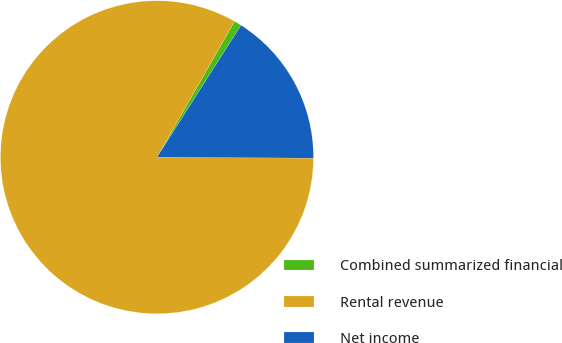<chart> <loc_0><loc_0><loc_500><loc_500><pie_chart><fcel>Combined summarized financial<fcel>Rental revenue<fcel>Net income<nl><fcel>0.77%<fcel>83.15%<fcel>16.07%<nl></chart> 